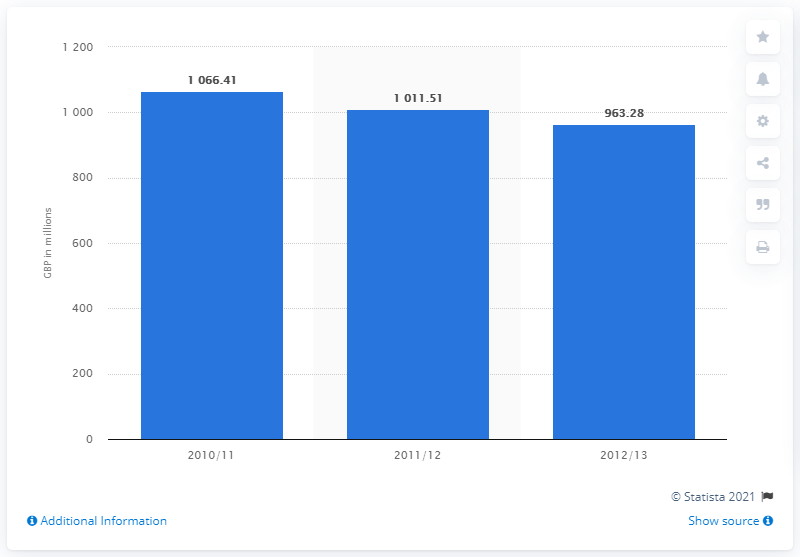Indicate a few pertinent items in this graphic. The amount spent on public libraries in 2012/13 was £963.28. 